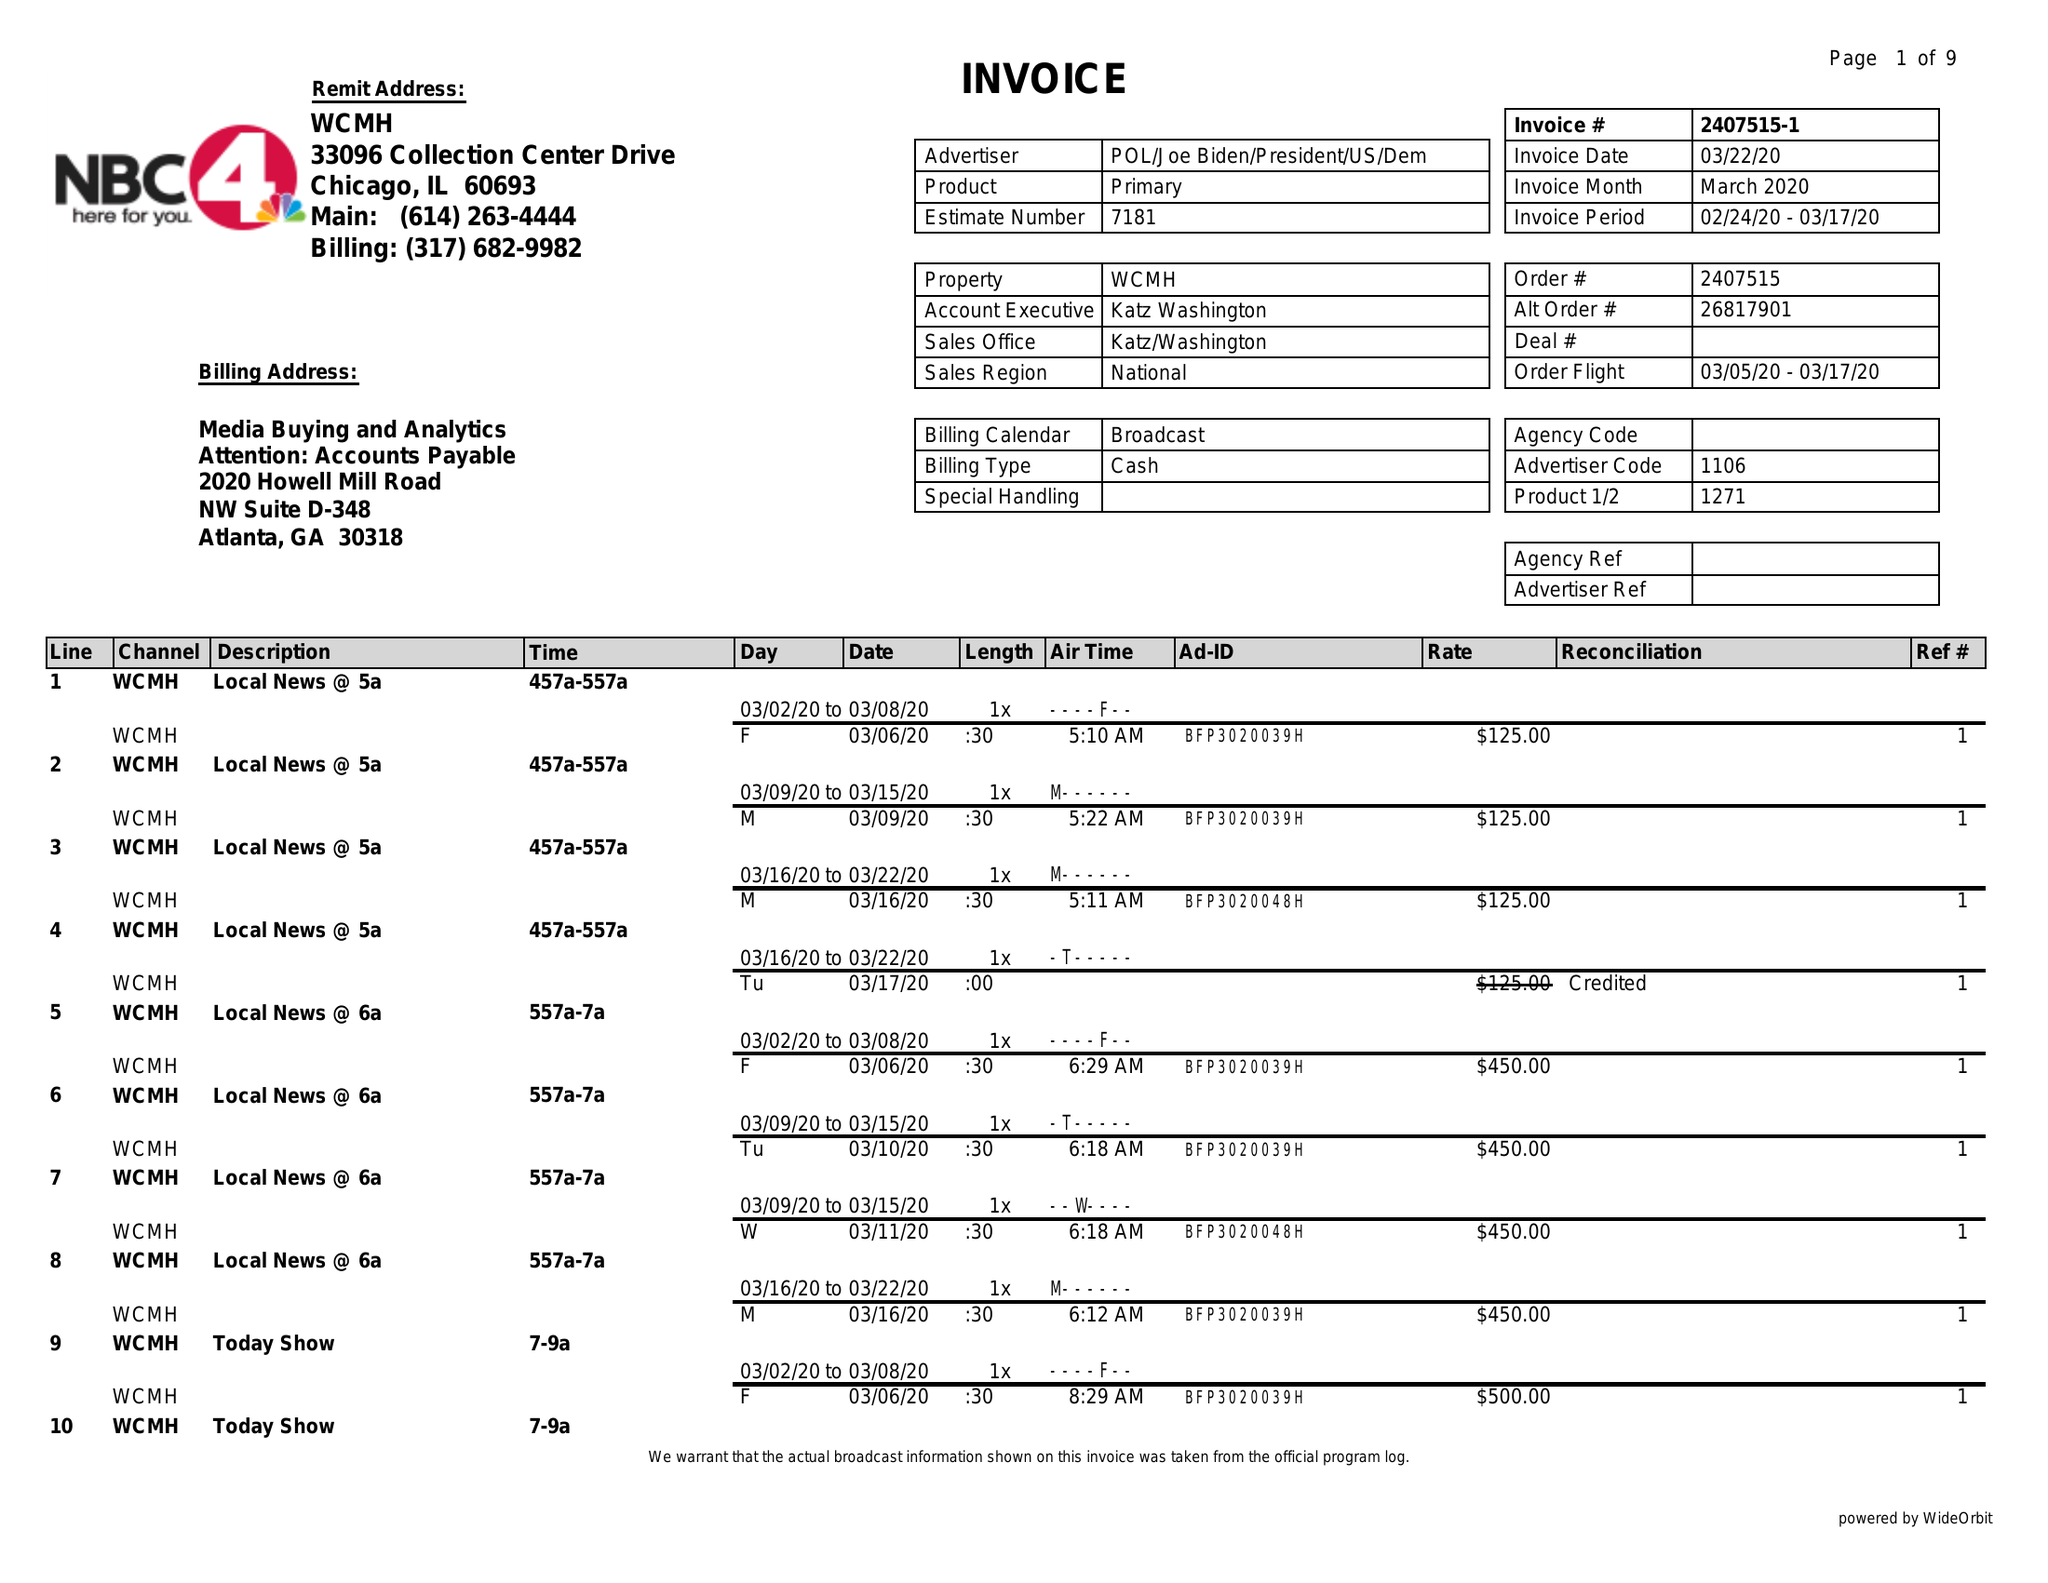What is the value for the gross_amount?
Answer the question using a single word or phrase. 25900.00 